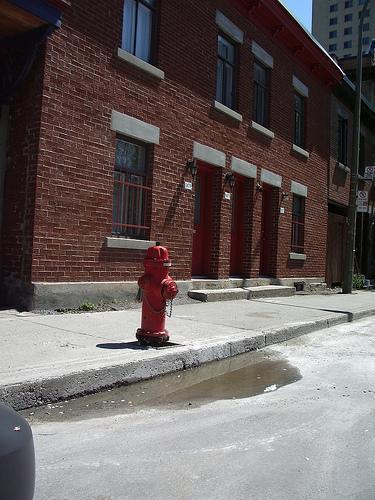How many red fire extinguishers complimented by silver chains are there?
Give a very brief answer. 1. 